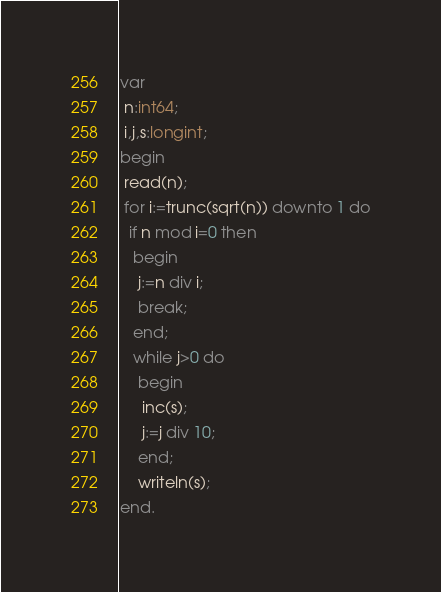<code> <loc_0><loc_0><loc_500><loc_500><_Pascal_>var
 n:int64;
 i,j,s:longint;
begin
 read(n);
 for i:=trunc(sqrt(n)) downto 1 do
  if n mod i=0 then
   begin
    j:=n div i;
    break;
   end;
   while j>0 do
    begin
     inc(s);
     j:=j div 10;
    end;
    writeln(s);
end.</code> 